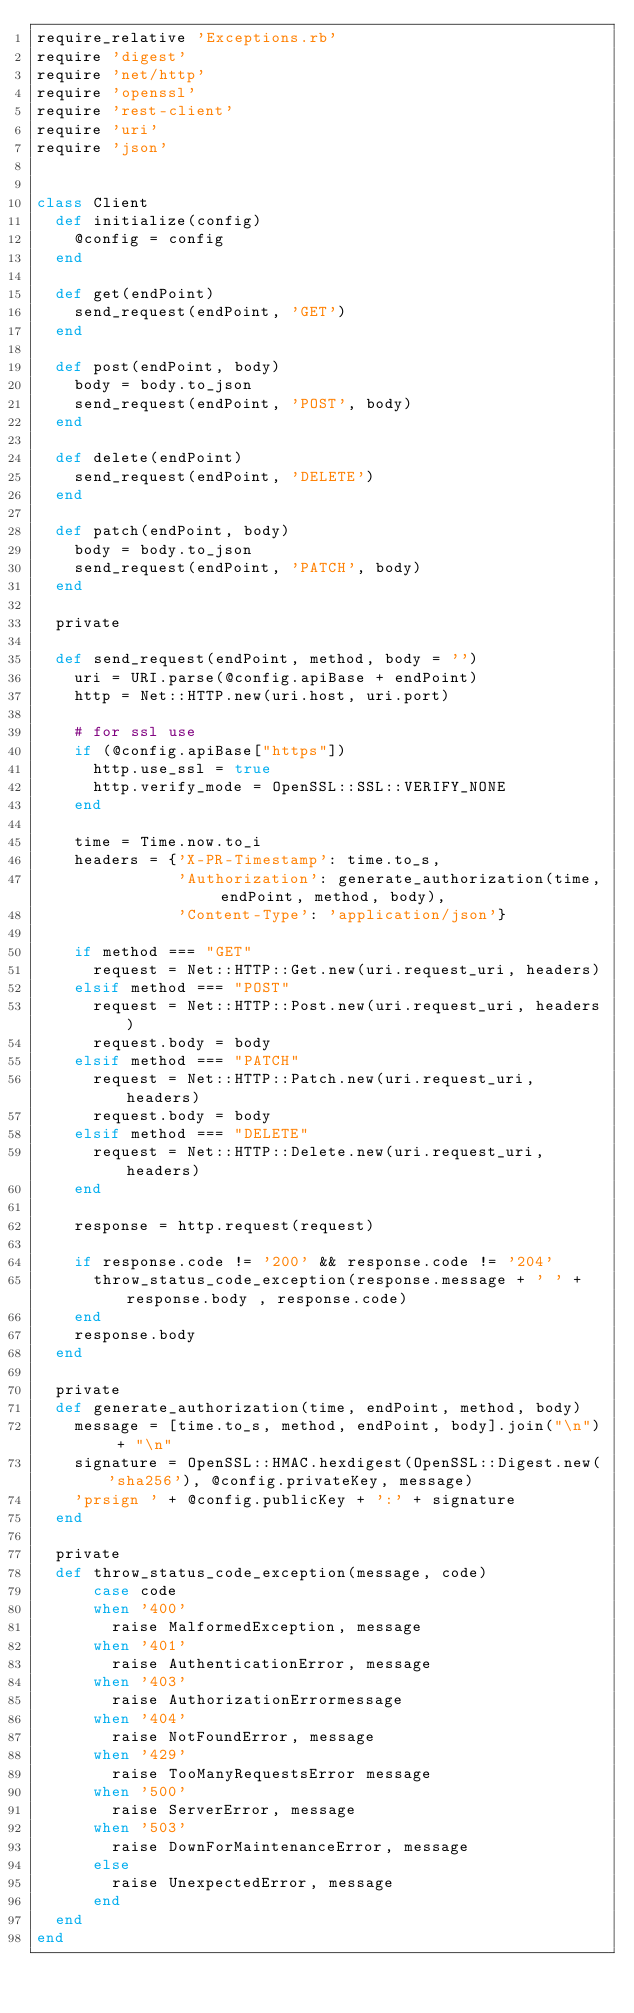Convert code to text. <code><loc_0><loc_0><loc_500><loc_500><_Ruby_>require_relative 'Exceptions.rb'
require 'digest'
require 'net/http'
require 'openssl'
require 'rest-client'
require 'uri'
require 'json'


class Client
  def initialize(config)
    @config = config
  end

  def get(endPoint)
    send_request(endPoint, 'GET')
  end

  def post(endPoint, body)
    body = body.to_json
    send_request(endPoint, 'POST', body)
  end

  def delete(endPoint)
    send_request(endPoint, 'DELETE')
  end

  def patch(endPoint, body)
    body = body.to_json
    send_request(endPoint, 'PATCH', body)
  end

  private

  def send_request(endPoint, method, body = '')
    uri = URI.parse(@config.apiBase + endPoint)
    http = Net::HTTP.new(uri.host, uri.port)

    # for ssl use
    if (@config.apiBase["https"])
      http.use_ssl = true
      http.verify_mode = OpenSSL::SSL::VERIFY_NONE
    end

    time = Time.now.to_i
    headers = {'X-PR-Timestamp': time.to_s,
               'Authorization': generate_authorization(time, endPoint, method, body),
               'Content-Type': 'application/json'}

    if method === "GET"
      request = Net::HTTP::Get.new(uri.request_uri, headers)
    elsif method === "POST"
      request = Net::HTTP::Post.new(uri.request_uri, headers)
      request.body = body
    elsif method === "PATCH"
      request = Net::HTTP::Patch.new(uri.request_uri, headers)
      request.body = body
    elsif method === "DELETE"
      request = Net::HTTP::Delete.new(uri.request_uri, headers)
    end

    response = http.request(request)

    if response.code != '200' && response.code != '204'
      throw_status_code_exception(response.message + ' ' + response.body , response.code)
    end
    response.body
  end

  private
  def generate_authorization(time, endPoint, method, body)
    message = [time.to_s, method, endPoint, body].join("\n") + "\n"
    signature = OpenSSL::HMAC.hexdigest(OpenSSL::Digest.new('sha256'), @config.privateKey, message)
    'prsign ' + @config.publicKey + ':' + signature
  end

  private
  def throw_status_code_exception(message, code)
      case code
      when '400'
        raise MalformedException, message
      when '401'
        raise AuthenticationError, message
      when '403'
        raise AuthorizationErrormessage
      when '404'
        raise NotFoundError, message
      when '429'
        raise TooManyRequestsError message
      when '500'
        raise ServerError, message
      when '503'
        raise DownForMaintenanceError, message
      else
        raise UnexpectedError, message
      end
  end
end





</code> 